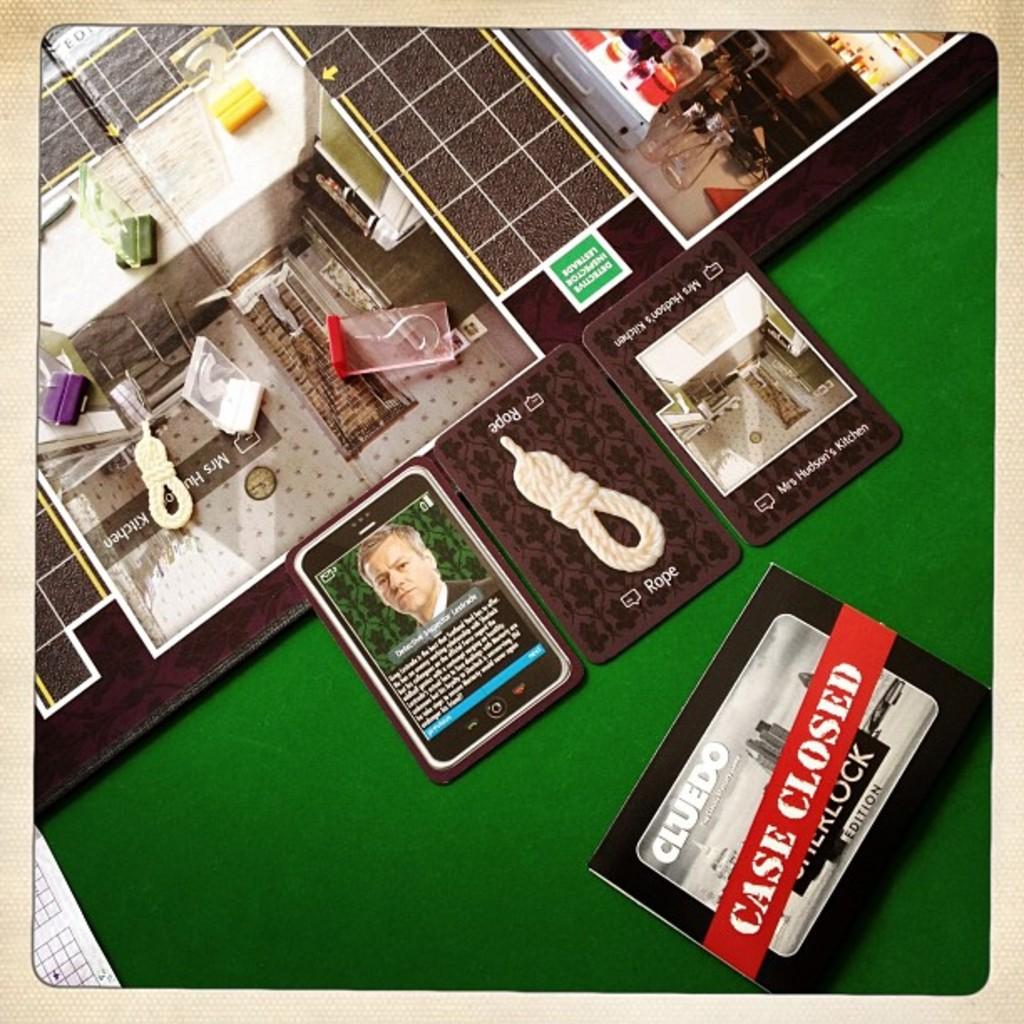What does the noose card say at the bottom?
Your answer should be compact. Rope. Is the case closed?
Give a very brief answer. Yes. 